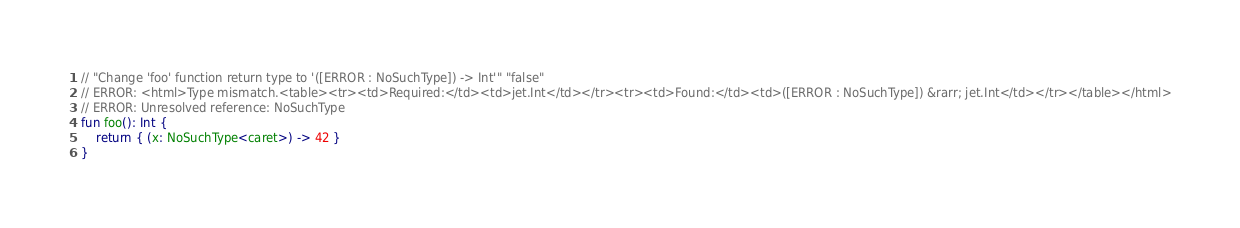<code> <loc_0><loc_0><loc_500><loc_500><_Kotlin_>// "Change 'foo' function return type to '([ERROR : NoSuchType]) -> Int'" "false"
// ERROR: <html>Type mismatch.<table><tr><td>Required:</td><td>jet.Int</td></tr><tr><td>Found:</td><td>([ERROR : NoSuchType]) &rarr; jet.Int</td></tr></table></html>
// ERROR: Unresolved reference: NoSuchType
fun foo(): Int {
    return { (x: NoSuchType<caret>) -> 42 }
}</code> 